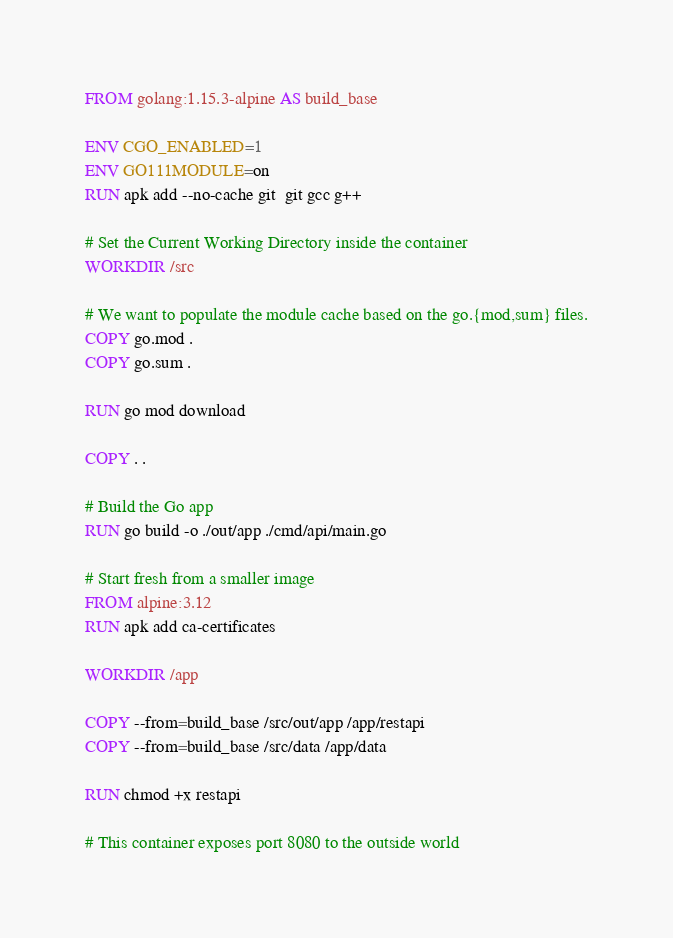<code> <loc_0><loc_0><loc_500><loc_500><_Dockerfile_>FROM golang:1.15.3-alpine AS build_base

ENV CGO_ENABLED=1
ENV GO111MODULE=on
RUN apk add --no-cache git  git gcc g++

# Set the Current Working Directory inside the container
WORKDIR /src

# We want to populate the module cache based on the go.{mod,sum} files.
COPY go.mod .
COPY go.sum .

RUN go mod download

COPY . .

# Build the Go app
RUN go build -o ./out/app ./cmd/api/main.go

# Start fresh from a smaller image
FROM alpine:3.12
RUN apk add ca-certificates

WORKDIR /app

COPY --from=build_base /src/out/app /app/restapi
COPY --from=build_base /src/data /app/data

RUN chmod +x restapi

# This container exposes port 8080 to the outside world</code> 